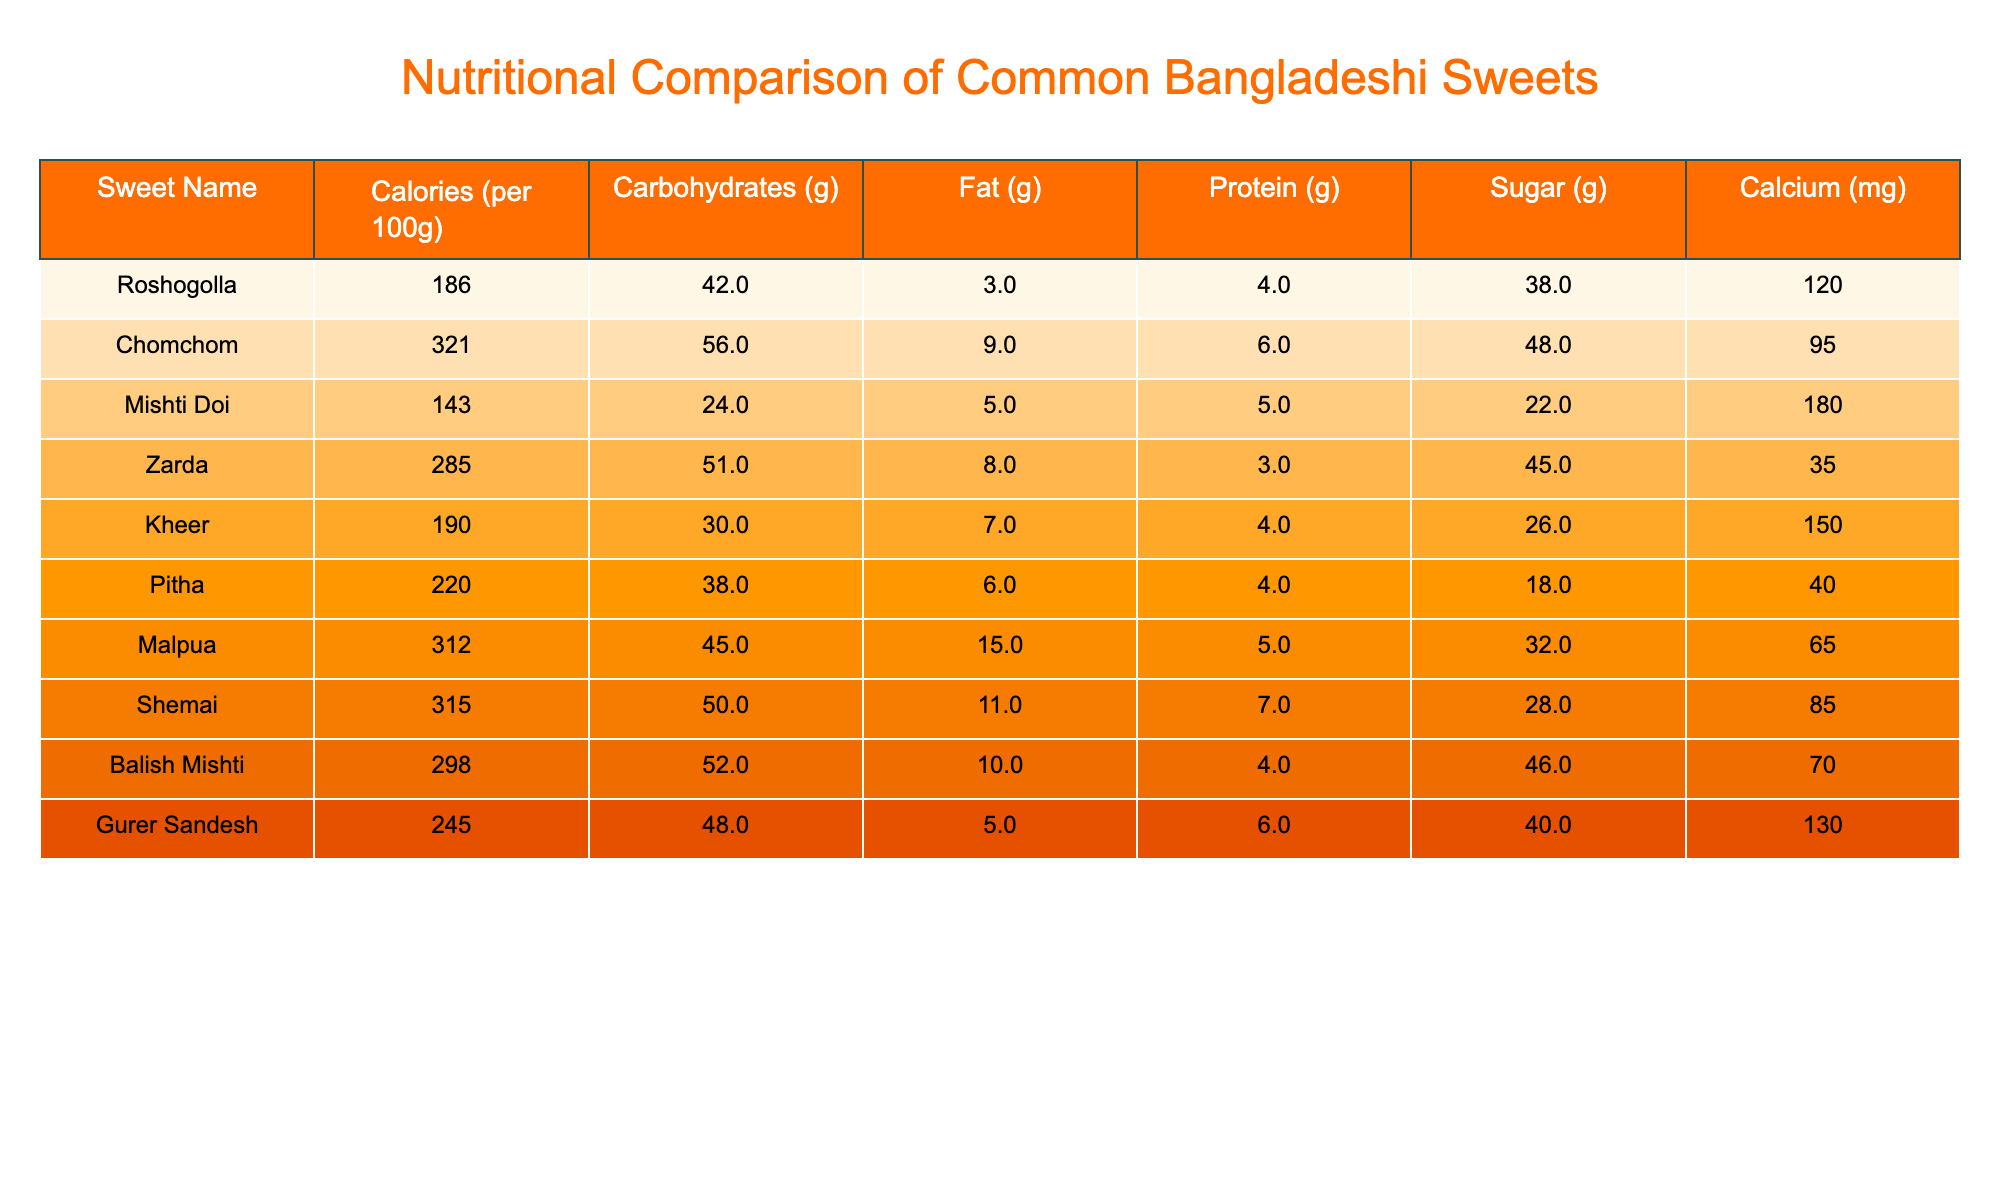What is the calorie content of Roshogolla? The table lists the calorie content for Roshogolla as 186 calories per 100g.
Answer: 186 calories Which sweet has the highest sugar content? By examining the sugar values, Chomchom has 48g of sugar, which is higher than any other sweet listed.
Answer: Chomchom What is the protein content of Mishti Doi? The table shows that each 100g of Mishti Doi contains 5g of protein.
Answer: 5g How many grams of carbohydrates are there in Malpua? The carbohydrate content for Malpua is specified as 45g per 100g.
Answer: 45g Which sweet has the lowest calcium content? By comparing the calcium values, Zarda has the lowest calcium content at 35mg.
Answer: Zarda What is the average amount of fat in the listed sweets? The fat content values are 3, 9, 5, 8, 7, 6, 15, 11, 10, and 5. The total fat is 3+9+5+8+7+6+15+11+10+5 = 79g, and there are 10 sweets, so the average is 79/10 = 7.9g.
Answer: 7.9g Is the protein content of Kheer greater than that of Pitha? Kheer contains 4g of protein while Pitha also has 4g; hence they are equal. The statement is false as they are not greater.
Answer: No What is the total sugar content of both Shemai and Balish Mishti combined? Shemai has 28g of sugar and Balish Mishti has 46g. Adding these two gives 28 + 46 = 74g of sugar.
Answer: 74g Which sweet has both higher carbohydrates and calories compared to Mishti Doi? Mishti Doi has 24g of carbohydrates and 143 calories. Chomchom has 56g of carbohydrates and 321 calories, which are both higher. Zarda also exceeds calories but not carbohydrates, making Chomchom the only qualifying sweet.
Answer: Chomchom What is the difference in calories between Shemai and Zarda? Shemai has 315 calories and Zarda has 285 calories. The difference is 315 - 285 = 30 calories.
Answer: 30 calories 